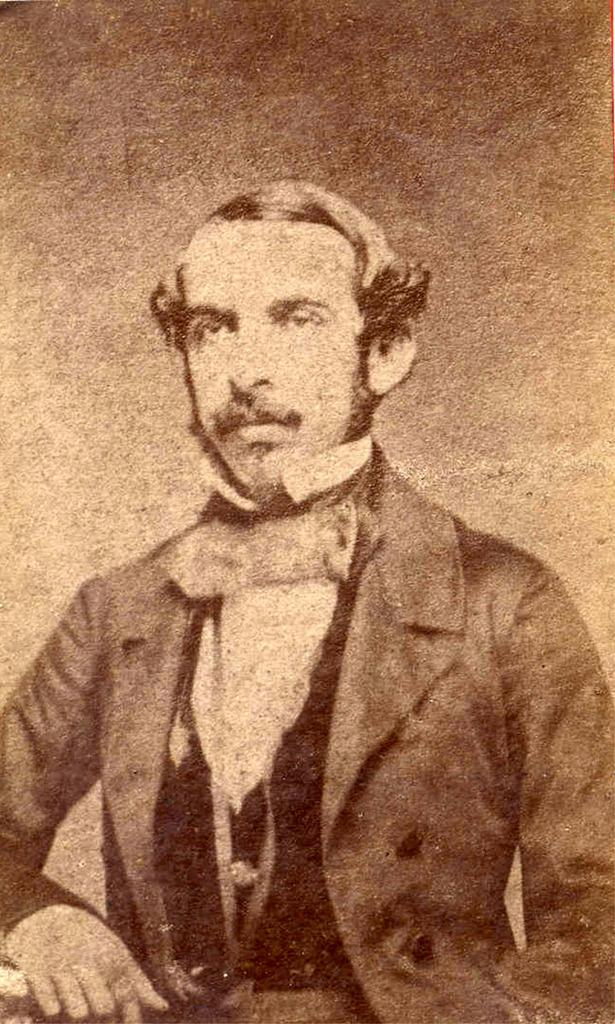What is the color scheme of the image? The image is black and white. Who is present in the image? There is a man in the image. What is the man wearing in the image? The man is wearing a coat in the image. How many horses are visible in the image? There are no horses present in the image. What type of territory is depicted in the image? The image does not depict any territory; it only features a man wearing a coat in a black and white setting. 